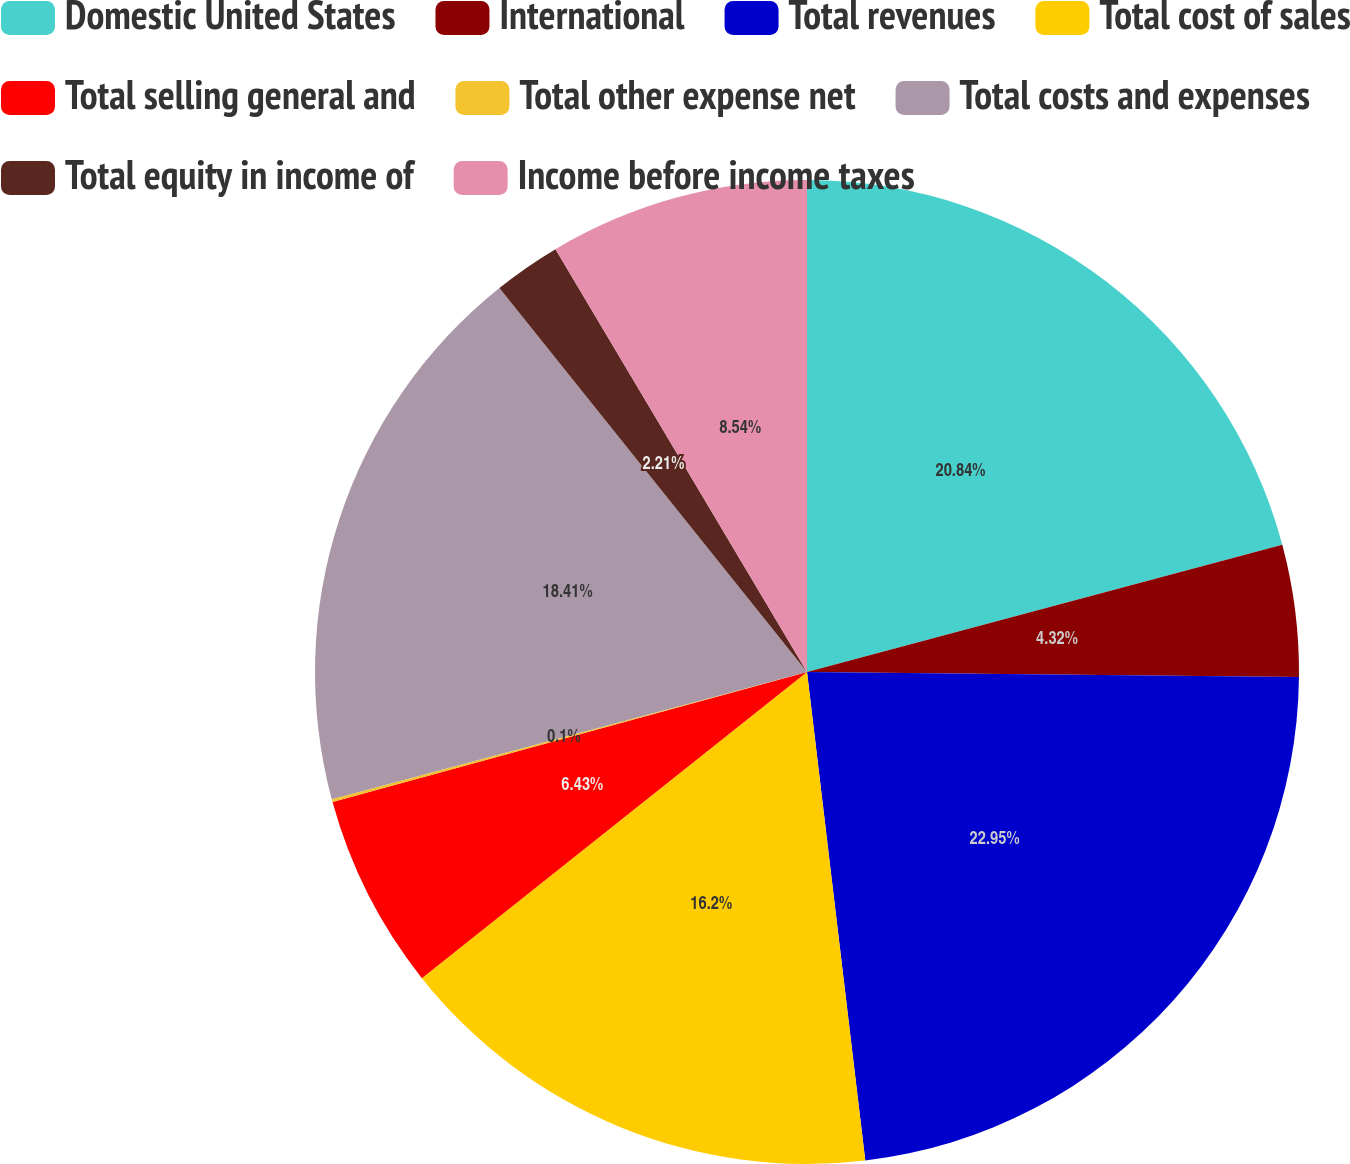Convert chart to OTSL. <chart><loc_0><loc_0><loc_500><loc_500><pie_chart><fcel>Domestic United States<fcel>International<fcel>Total revenues<fcel>Total cost of sales<fcel>Total selling general and<fcel>Total other expense net<fcel>Total costs and expenses<fcel>Total equity in income of<fcel>Income before income taxes<nl><fcel>20.84%<fcel>4.32%<fcel>22.95%<fcel>16.2%<fcel>6.43%<fcel>0.1%<fcel>18.41%<fcel>2.21%<fcel>8.54%<nl></chart> 